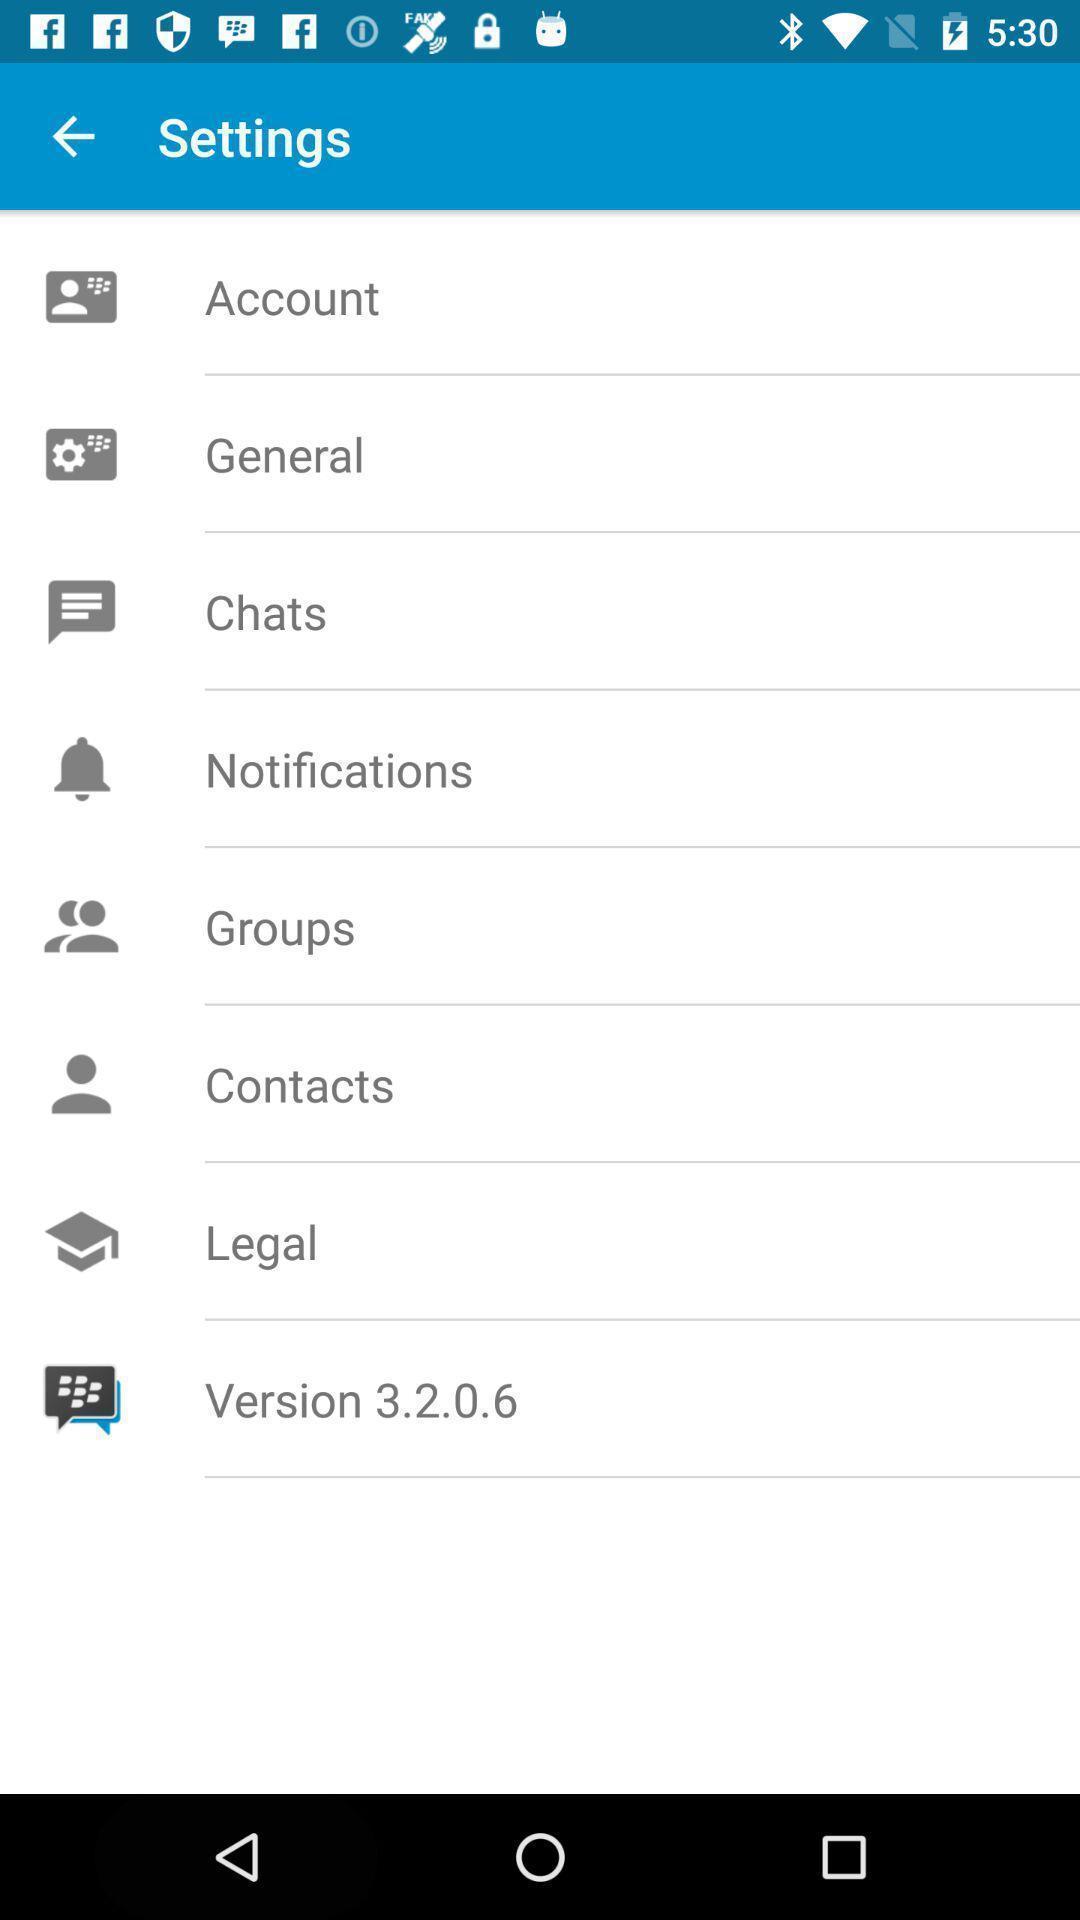Provide a textual representation of this image. Settings page. 